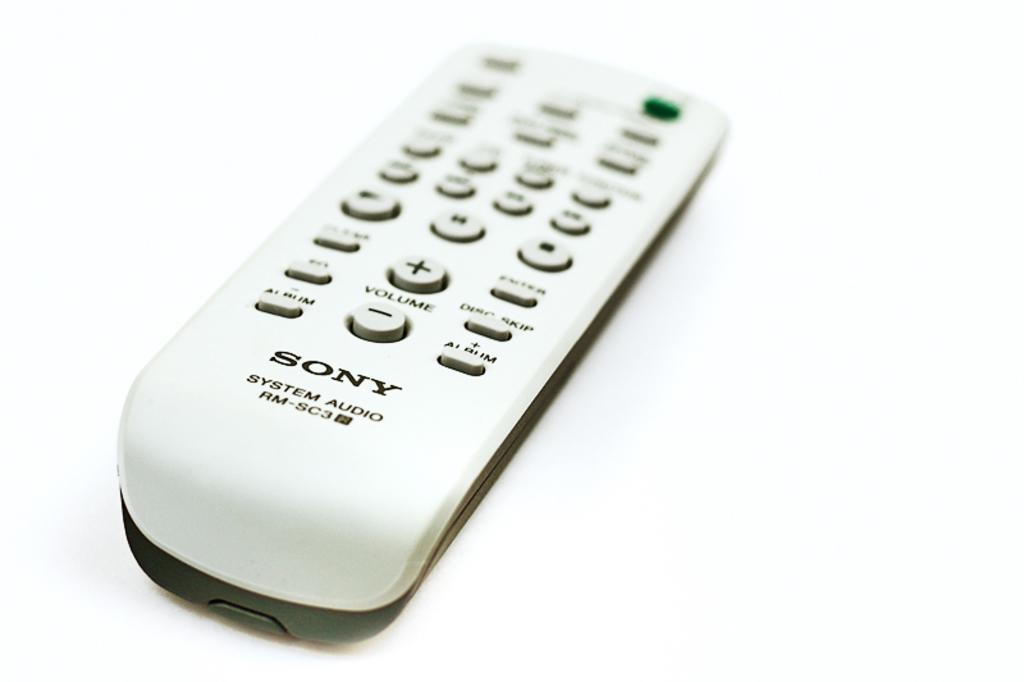What brand remote is this?
Your response must be concise. Sony. What brand is the remote control?
Your answer should be compact. Sony. 